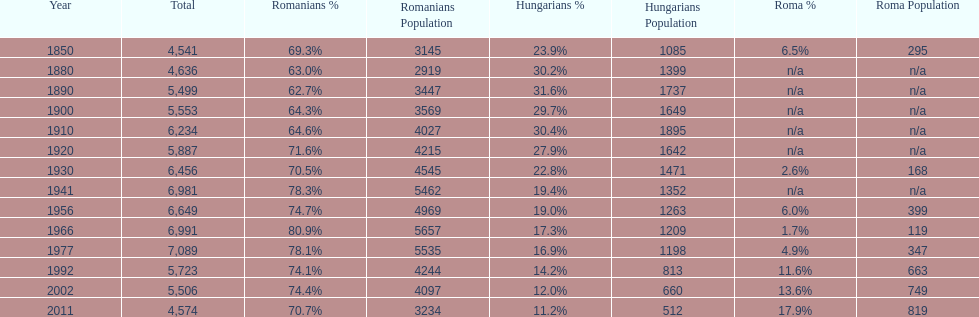What year had the highest total number? 1977. 